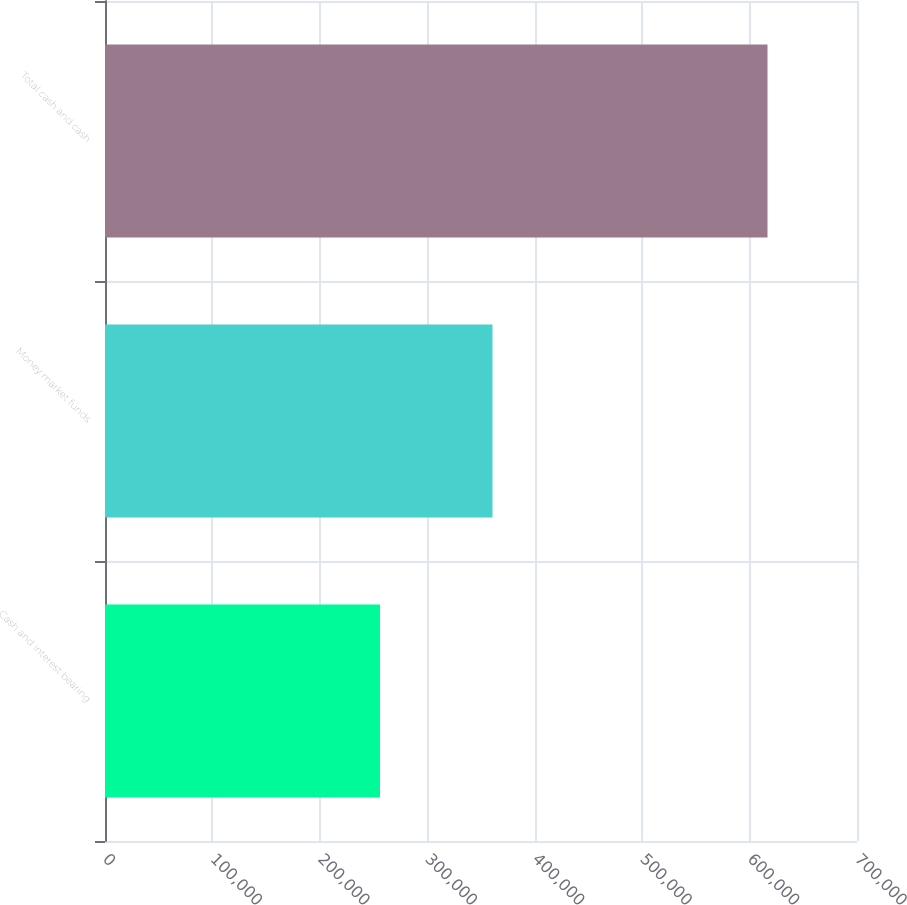Convert chart to OTSL. <chart><loc_0><loc_0><loc_500><loc_500><bar_chart><fcel>Cash and interest bearing<fcel>Money market funds<fcel>Total cash and cash<nl><fcel>255995<fcel>360691<fcel>616686<nl></chart> 